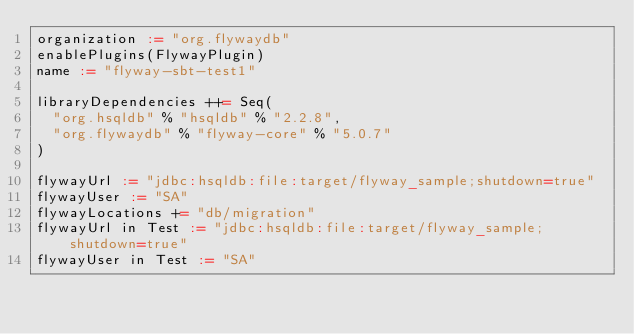Convert code to text. <code><loc_0><loc_0><loc_500><loc_500><_Scala_>organization := "org.flywaydb"
enablePlugins(FlywayPlugin)
name := "flyway-sbt-test1"

libraryDependencies ++= Seq(
  "org.hsqldb" % "hsqldb" % "2.2.8",
  "org.flywaydb" % "flyway-core" % "5.0.7"
)

flywayUrl := "jdbc:hsqldb:file:target/flyway_sample;shutdown=true"
flywayUser := "SA"
flywayLocations += "db/migration"
flywayUrl in Test := "jdbc:hsqldb:file:target/flyway_sample;shutdown=true"
flywayUser in Test := "SA"
</code> 